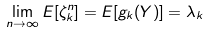<formula> <loc_0><loc_0><loc_500><loc_500>\lim _ { n \rightarrow \infty } E [ \zeta _ { k } ^ { n } ] = E [ g _ { k } ( Y ) ] = \lambda _ { k }</formula> 